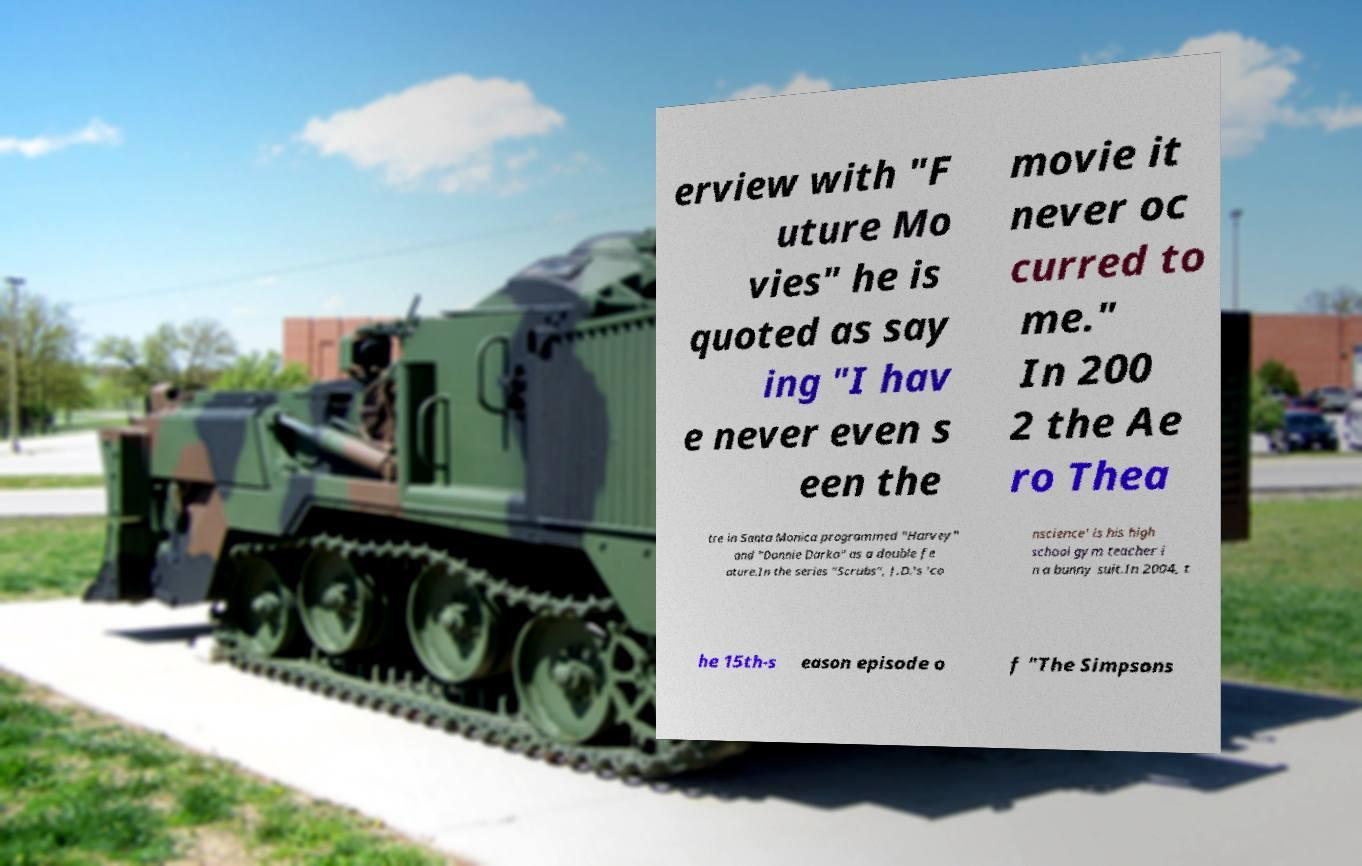For documentation purposes, I need the text within this image transcribed. Could you provide that? erview with "F uture Mo vies" he is quoted as say ing "I hav e never even s een the movie it never oc curred to me." In 200 2 the Ae ro Thea tre in Santa Monica programmed "Harvey" and "Donnie Darko" as a double fe ature.In the series "Scrubs", J.D.'s 'co nscience' is his high school gym teacher i n a bunny suit.In 2004, t he 15th-s eason episode o f "The Simpsons 